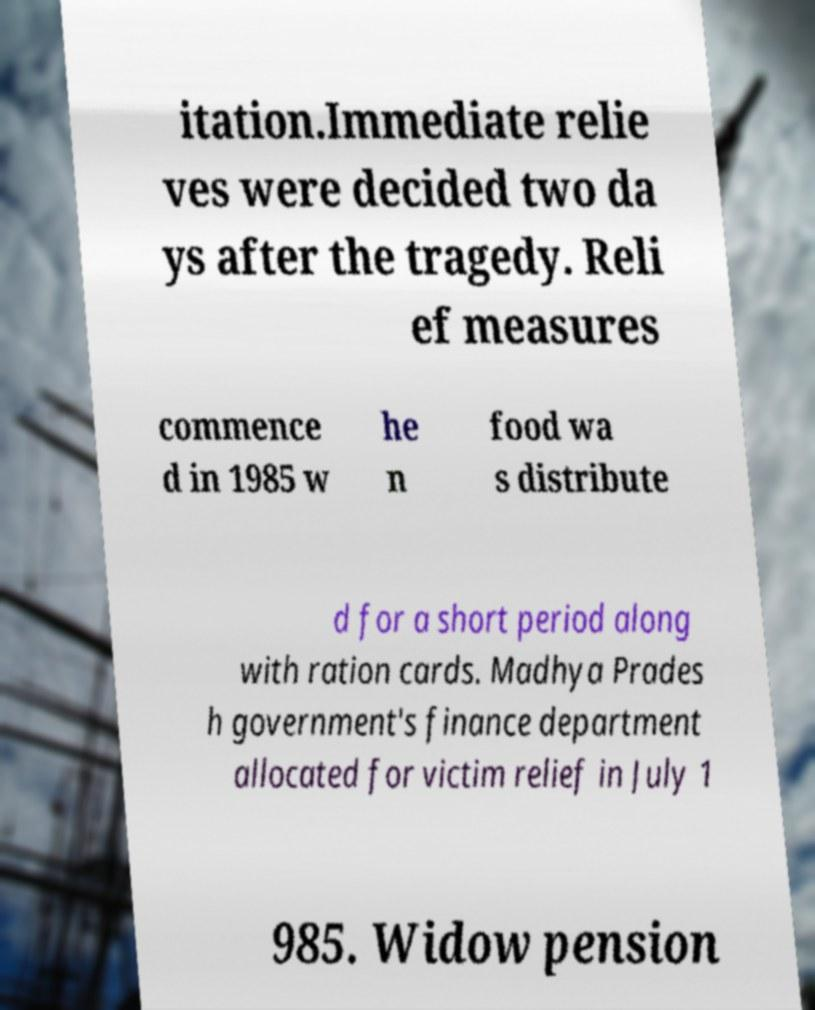Please identify and transcribe the text found in this image. itation.Immediate relie ves were decided two da ys after the tragedy. Reli ef measures commence d in 1985 w he n food wa s distribute d for a short period along with ration cards. Madhya Prades h government's finance department allocated for victim relief in July 1 985. Widow pension 